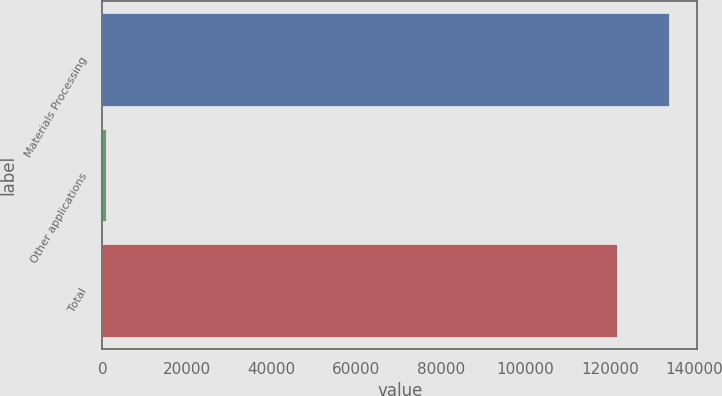Convert chart to OTSL. <chart><loc_0><loc_0><loc_500><loc_500><bar_chart><fcel>Materials Processing<fcel>Other applications<fcel>Total<nl><fcel>133978<fcel>774<fcel>121798<nl></chart> 